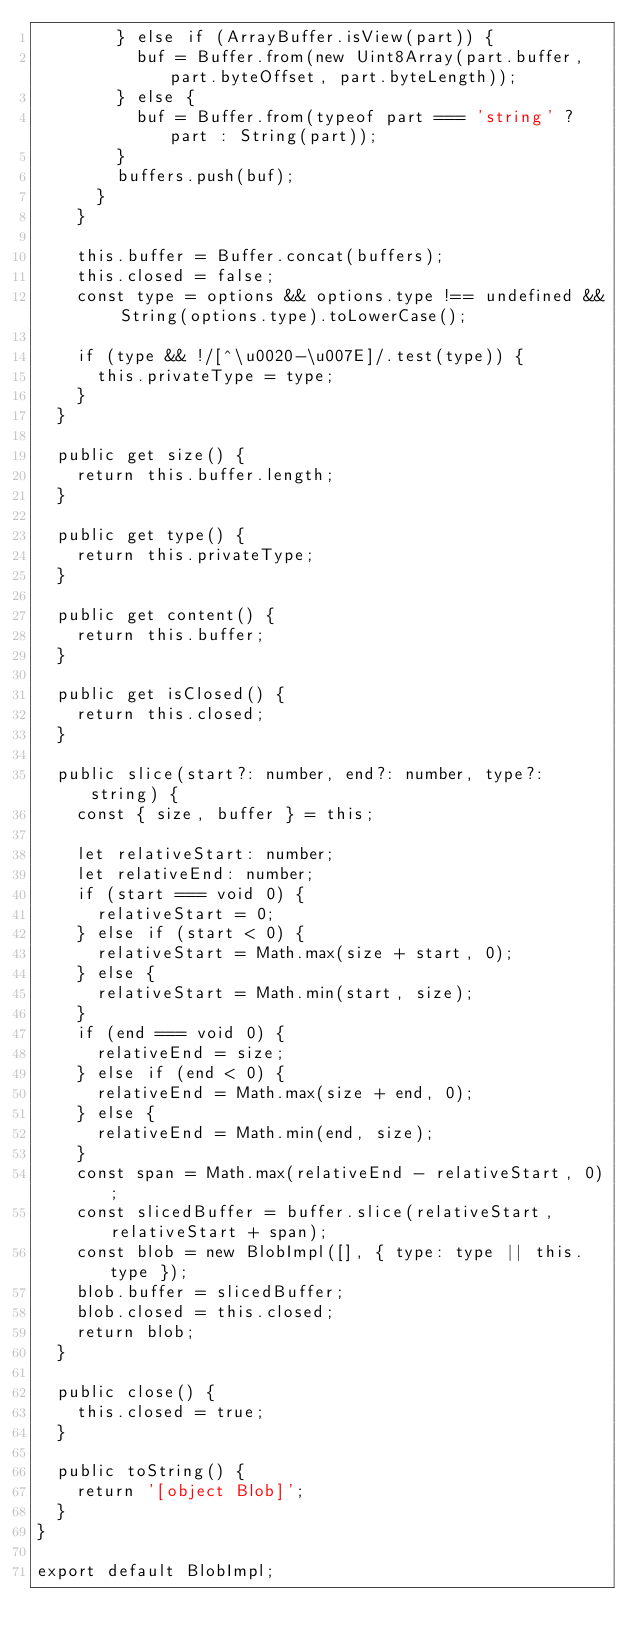<code> <loc_0><loc_0><loc_500><loc_500><_TypeScript_>        } else if (ArrayBuffer.isView(part)) {
          buf = Buffer.from(new Uint8Array(part.buffer, part.byteOffset, part.byteLength));
        } else {
          buf = Buffer.from(typeof part === 'string' ? part : String(part));
        }
        buffers.push(buf);
      }
    }

    this.buffer = Buffer.concat(buffers);
    this.closed = false;
    const type = options && options.type !== undefined && String(options.type).toLowerCase();

    if (type && !/[^\u0020-\u007E]/.test(type)) {
      this.privateType = type;
    }
  }

  public get size() {
    return this.buffer.length;
  }

  public get type() {
    return this.privateType;
  }

  public get content() {
    return this.buffer;
  }

  public get isClosed() {
    return this.closed;
  }

  public slice(start?: number, end?: number, type?: string) {
    const { size, buffer } = this;

    let relativeStart: number;
    let relativeEnd: number;
    if (start === void 0) {
      relativeStart = 0;
    } else if (start < 0) {
      relativeStart = Math.max(size + start, 0);
    } else {
      relativeStart = Math.min(start, size);
    }
    if (end === void 0) {
      relativeEnd = size;
    } else if (end < 0) {
      relativeEnd = Math.max(size + end, 0);
    } else {
      relativeEnd = Math.min(end, size);
    }
    const span = Math.max(relativeEnd - relativeStart, 0);
    const slicedBuffer = buffer.slice(relativeStart, relativeStart + span);
    const blob = new BlobImpl([], { type: type || this.type });
    blob.buffer = slicedBuffer;
    blob.closed = this.closed;
    return blob;
  }

  public close() {
    this.closed = true;
  }

  public toString() {
    return '[object Blob]';
  }
}

export default BlobImpl;
</code> 